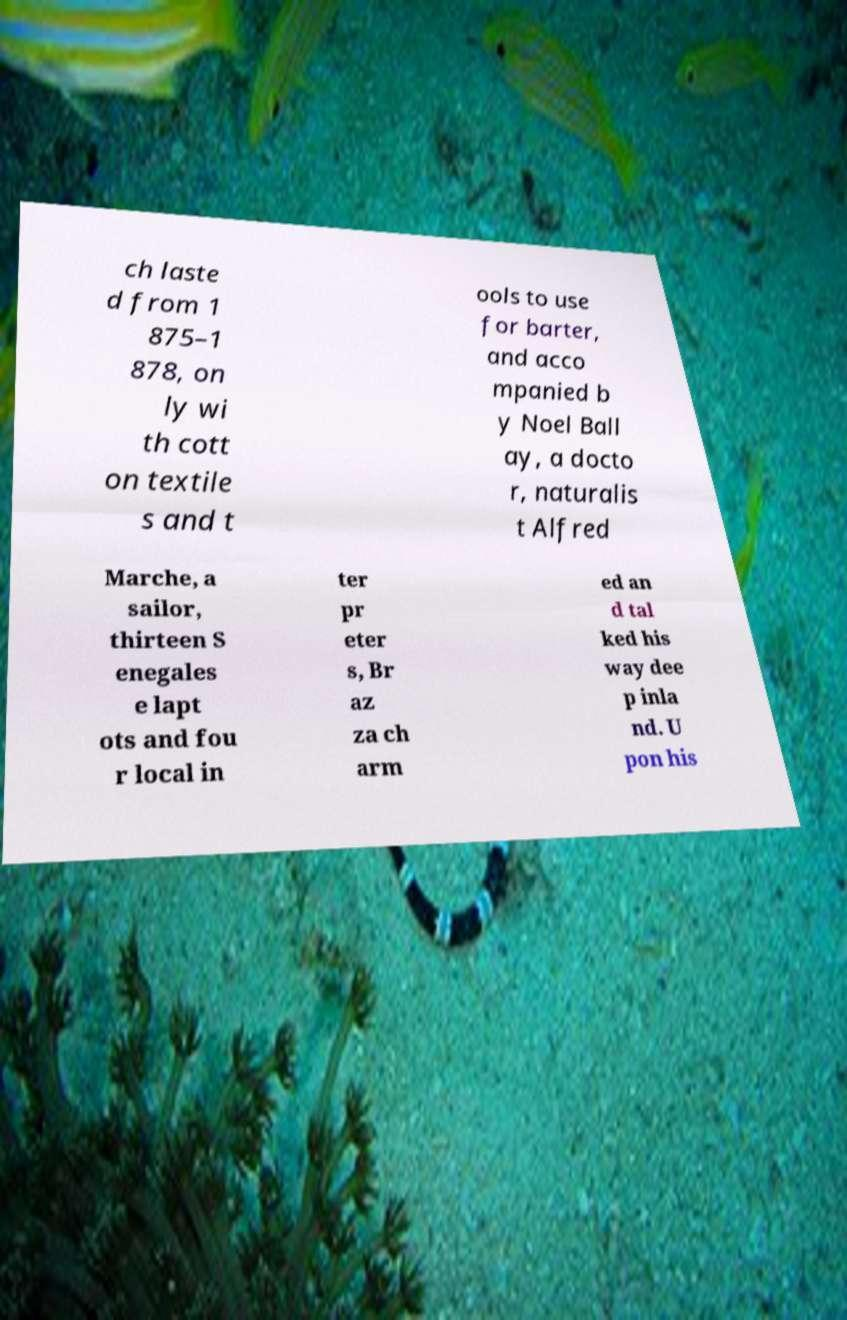Please read and relay the text visible in this image. What does it say? ch laste d from 1 875–1 878, on ly wi th cott on textile s and t ools to use for barter, and acco mpanied b y Noel Ball ay, a docto r, naturalis t Alfred Marche, a sailor, thirteen S enegales e lapt ots and fou r local in ter pr eter s, Br az za ch arm ed an d tal ked his way dee p inla nd. U pon his 